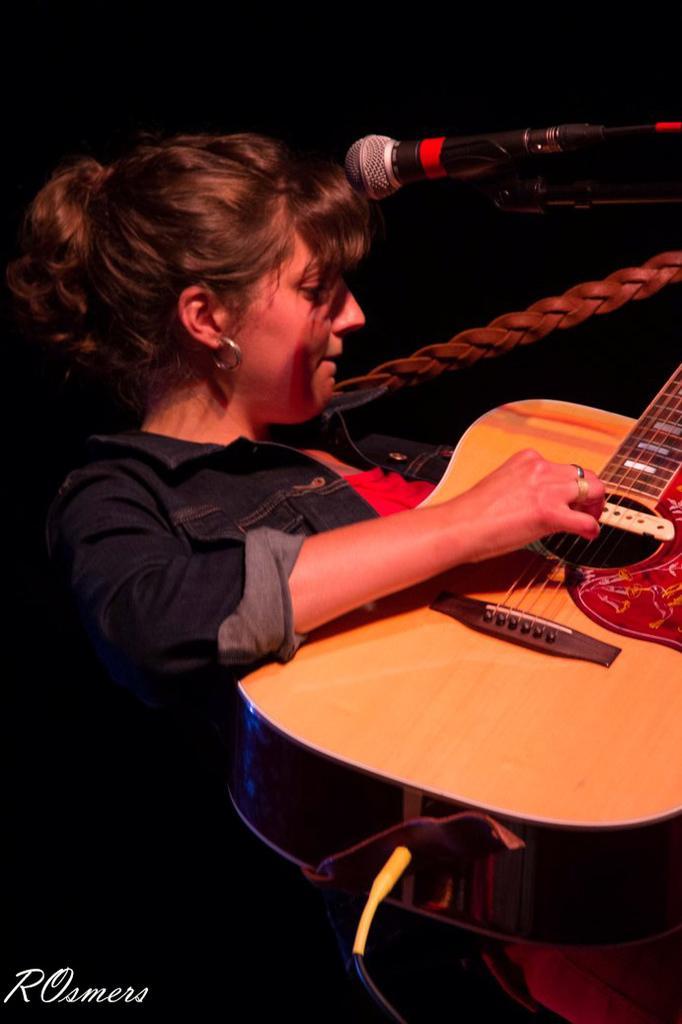In one or two sentences, can you explain what this image depicts? In this picture a woman is playing guitar. On the top right there is a microphone. Background is dark. Woman is wearing a denim shirt. In the foreground a cable can be seen. 